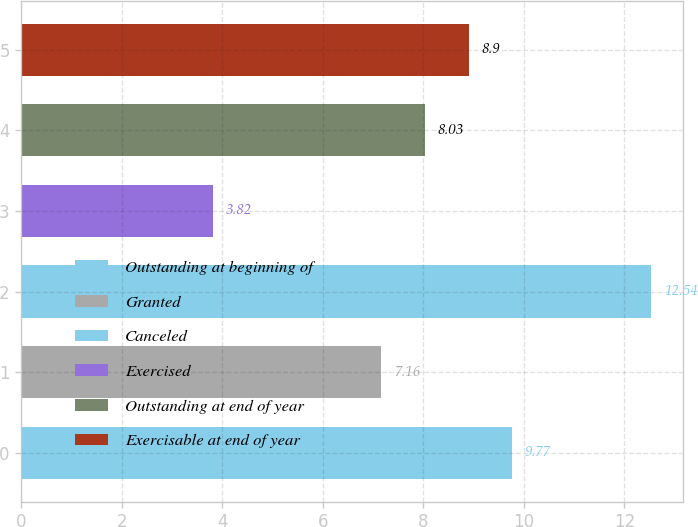Convert chart to OTSL. <chart><loc_0><loc_0><loc_500><loc_500><bar_chart><fcel>Outstanding at beginning of<fcel>Granted<fcel>Canceled<fcel>Exercised<fcel>Outstanding at end of year<fcel>Exercisable at end of year<nl><fcel>9.77<fcel>7.16<fcel>12.54<fcel>3.82<fcel>8.03<fcel>8.9<nl></chart> 